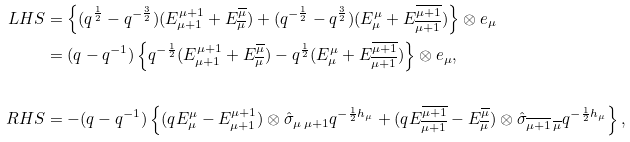<formula> <loc_0><loc_0><loc_500><loc_500>L H S & = \left \{ ( q ^ { \frac { 1 } { 2 } } - q ^ { - \frac { 3 } { 2 } } ) ( E ^ { \mu + 1 } _ { \mu + 1 } + E ^ { \overline { \mu } } _ { \overline { \mu } } ) + ( q ^ { - \frac { 1 } { 2 } } - q ^ { \frac { 3 } { 2 } } ) ( E ^ { \mu } _ { \mu } + E ^ { \overline { \mu + 1 } } _ { \overline { \mu + 1 } } ) \right \} \otimes e _ { \mu } \\ & = ( q - q ^ { - 1 } ) \left \{ q ^ { - \frac { 1 } { 2 } } ( E ^ { \mu + 1 } _ { \mu + 1 } + E ^ { \overline { \mu } } _ { \overline { \mu } } ) - q ^ { \frac { 1 } { 2 } } ( E ^ { \mu } _ { \mu } + E ^ { \overline { \mu + 1 } } _ { \overline { \mu + 1 } } ) \right \} \otimes e _ { \mu } , \\ \\ R H S & = - ( q - q ^ { - 1 } ) \left \{ ( q E ^ { \mu } _ { \mu } - E ^ { \mu + 1 } _ { \mu + 1 } ) \otimes \hat { \sigma } _ { \mu \, \mu + 1 } q ^ { - \frac { 1 } { 2 } h _ { \mu } } + ( q E ^ { \overline { \mu + 1 } } _ { \overline { \mu + 1 } } - E ^ { \overline { \mu } } _ { \overline { \mu } } ) \otimes \hat { \sigma } _ { \overline { \mu + 1 } \, \overline { \mu } } q ^ { - \frac { 1 } { 2 } h _ { \mu } } \right \} ,</formula> 